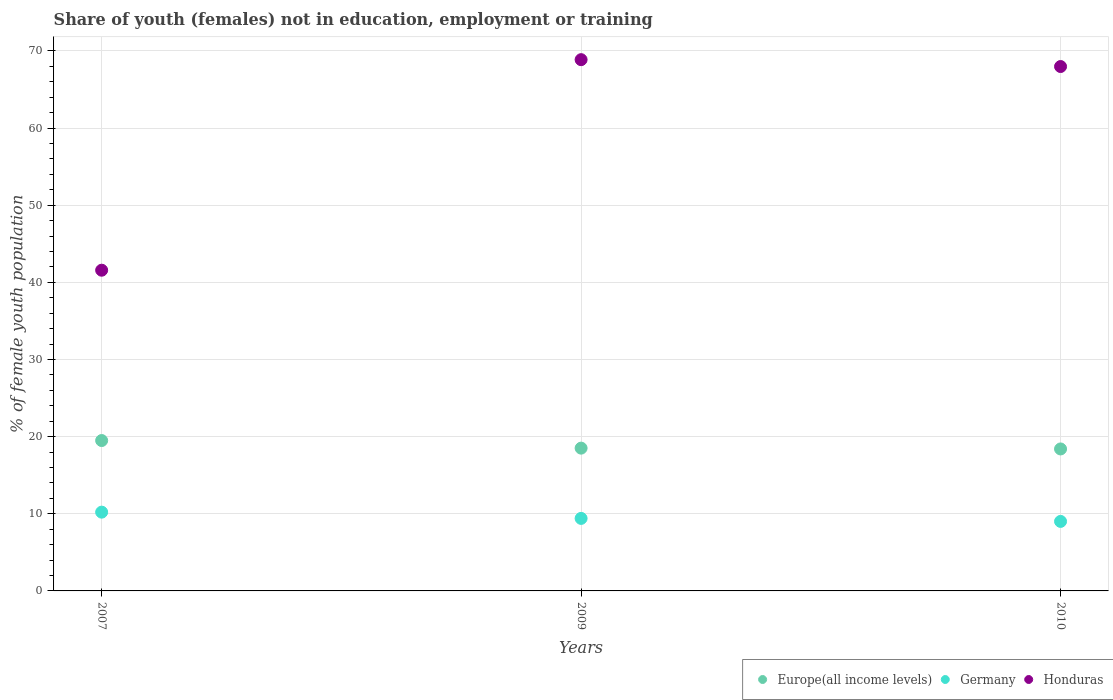What is the percentage of unemployed female population in in Germany in 2010?
Ensure brevity in your answer.  9.01. Across all years, what is the maximum percentage of unemployed female population in in Europe(all income levels)?
Provide a succinct answer. 19.49. Across all years, what is the minimum percentage of unemployed female population in in Germany?
Make the answer very short. 9.01. What is the total percentage of unemployed female population in in Europe(all income levels) in the graph?
Ensure brevity in your answer.  56.4. What is the difference between the percentage of unemployed female population in in Germany in 2007 and that in 2009?
Provide a short and direct response. 0.81. What is the difference between the percentage of unemployed female population in in Europe(all income levels) in 2009 and the percentage of unemployed female population in in Germany in 2010?
Your answer should be very brief. 9.5. What is the average percentage of unemployed female population in in Europe(all income levels) per year?
Offer a terse response. 18.8. In the year 2009, what is the difference between the percentage of unemployed female population in in Germany and percentage of unemployed female population in in Europe(all income levels)?
Your response must be concise. -9.11. What is the ratio of the percentage of unemployed female population in in Germany in 2007 to that in 2010?
Your answer should be very brief. 1.13. Is the percentage of unemployed female population in in Germany in 2007 less than that in 2009?
Give a very brief answer. No. What is the difference between the highest and the second highest percentage of unemployed female population in in Europe(all income levels)?
Make the answer very short. 0.98. What is the difference between the highest and the lowest percentage of unemployed female population in in Germany?
Ensure brevity in your answer.  1.2. In how many years, is the percentage of unemployed female population in in Europe(all income levels) greater than the average percentage of unemployed female population in in Europe(all income levels) taken over all years?
Make the answer very short. 1. Is it the case that in every year, the sum of the percentage of unemployed female population in in Germany and percentage of unemployed female population in in Europe(all income levels)  is greater than the percentage of unemployed female population in in Honduras?
Offer a very short reply. No. Is the percentage of unemployed female population in in Europe(all income levels) strictly greater than the percentage of unemployed female population in in Honduras over the years?
Provide a succinct answer. No. Is the percentage of unemployed female population in in Germany strictly less than the percentage of unemployed female population in in Europe(all income levels) over the years?
Provide a short and direct response. Yes. How many dotlines are there?
Your answer should be very brief. 3. How many years are there in the graph?
Give a very brief answer. 3. What is the difference between two consecutive major ticks on the Y-axis?
Your response must be concise. 10. Are the values on the major ticks of Y-axis written in scientific E-notation?
Make the answer very short. No. Where does the legend appear in the graph?
Ensure brevity in your answer.  Bottom right. What is the title of the graph?
Provide a succinct answer. Share of youth (females) not in education, employment or training. What is the label or title of the Y-axis?
Offer a terse response. % of female youth population. What is the % of female youth population in Europe(all income levels) in 2007?
Offer a terse response. 19.49. What is the % of female youth population in Germany in 2007?
Keep it short and to the point. 10.21. What is the % of female youth population of Honduras in 2007?
Make the answer very short. 41.57. What is the % of female youth population in Europe(all income levels) in 2009?
Keep it short and to the point. 18.51. What is the % of female youth population in Germany in 2009?
Make the answer very short. 9.4. What is the % of female youth population in Honduras in 2009?
Ensure brevity in your answer.  68.86. What is the % of female youth population in Europe(all income levels) in 2010?
Provide a succinct answer. 18.4. What is the % of female youth population of Germany in 2010?
Ensure brevity in your answer.  9.01. What is the % of female youth population in Honduras in 2010?
Your answer should be very brief. 67.97. Across all years, what is the maximum % of female youth population in Europe(all income levels)?
Your answer should be very brief. 19.49. Across all years, what is the maximum % of female youth population of Germany?
Offer a terse response. 10.21. Across all years, what is the maximum % of female youth population of Honduras?
Ensure brevity in your answer.  68.86. Across all years, what is the minimum % of female youth population of Europe(all income levels)?
Your answer should be very brief. 18.4. Across all years, what is the minimum % of female youth population in Germany?
Keep it short and to the point. 9.01. Across all years, what is the minimum % of female youth population of Honduras?
Keep it short and to the point. 41.57. What is the total % of female youth population of Europe(all income levels) in the graph?
Provide a short and direct response. 56.4. What is the total % of female youth population of Germany in the graph?
Your response must be concise. 28.62. What is the total % of female youth population in Honduras in the graph?
Your answer should be very brief. 178.4. What is the difference between the % of female youth population of Europe(all income levels) in 2007 and that in 2009?
Provide a short and direct response. 0.98. What is the difference between the % of female youth population in Germany in 2007 and that in 2009?
Offer a very short reply. 0.81. What is the difference between the % of female youth population in Honduras in 2007 and that in 2009?
Your answer should be compact. -27.29. What is the difference between the % of female youth population in Europe(all income levels) in 2007 and that in 2010?
Your response must be concise. 1.09. What is the difference between the % of female youth population in Germany in 2007 and that in 2010?
Your answer should be very brief. 1.2. What is the difference between the % of female youth population in Honduras in 2007 and that in 2010?
Ensure brevity in your answer.  -26.4. What is the difference between the % of female youth population in Europe(all income levels) in 2009 and that in 2010?
Keep it short and to the point. 0.1. What is the difference between the % of female youth population in Germany in 2009 and that in 2010?
Your response must be concise. 0.39. What is the difference between the % of female youth population in Honduras in 2009 and that in 2010?
Provide a succinct answer. 0.89. What is the difference between the % of female youth population of Europe(all income levels) in 2007 and the % of female youth population of Germany in 2009?
Provide a succinct answer. 10.09. What is the difference between the % of female youth population of Europe(all income levels) in 2007 and the % of female youth population of Honduras in 2009?
Keep it short and to the point. -49.37. What is the difference between the % of female youth population in Germany in 2007 and the % of female youth population in Honduras in 2009?
Provide a succinct answer. -58.65. What is the difference between the % of female youth population in Europe(all income levels) in 2007 and the % of female youth population in Germany in 2010?
Provide a succinct answer. 10.48. What is the difference between the % of female youth population of Europe(all income levels) in 2007 and the % of female youth population of Honduras in 2010?
Offer a terse response. -48.48. What is the difference between the % of female youth population in Germany in 2007 and the % of female youth population in Honduras in 2010?
Offer a terse response. -57.76. What is the difference between the % of female youth population of Europe(all income levels) in 2009 and the % of female youth population of Germany in 2010?
Keep it short and to the point. 9.5. What is the difference between the % of female youth population of Europe(all income levels) in 2009 and the % of female youth population of Honduras in 2010?
Keep it short and to the point. -49.46. What is the difference between the % of female youth population of Germany in 2009 and the % of female youth population of Honduras in 2010?
Make the answer very short. -58.57. What is the average % of female youth population in Europe(all income levels) per year?
Your response must be concise. 18.8. What is the average % of female youth population of Germany per year?
Provide a short and direct response. 9.54. What is the average % of female youth population of Honduras per year?
Provide a succinct answer. 59.47. In the year 2007, what is the difference between the % of female youth population in Europe(all income levels) and % of female youth population in Germany?
Your answer should be compact. 9.28. In the year 2007, what is the difference between the % of female youth population in Europe(all income levels) and % of female youth population in Honduras?
Offer a very short reply. -22.08. In the year 2007, what is the difference between the % of female youth population in Germany and % of female youth population in Honduras?
Give a very brief answer. -31.36. In the year 2009, what is the difference between the % of female youth population of Europe(all income levels) and % of female youth population of Germany?
Offer a terse response. 9.11. In the year 2009, what is the difference between the % of female youth population of Europe(all income levels) and % of female youth population of Honduras?
Offer a very short reply. -50.35. In the year 2009, what is the difference between the % of female youth population in Germany and % of female youth population in Honduras?
Provide a succinct answer. -59.46. In the year 2010, what is the difference between the % of female youth population in Europe(all income levels) and % of female youth population in Germany?
Keep it short and to the point. 9.39. In the year 2010, what is the difference between the % of female youth population in Europe(all income levels) and % of female youth population in Honduras?
Ensure brevity in your answer.  -49.57. In the year 2010, what is the difference between the % of female youth population in Germany and % of female youth population in Honduras?
Your answer should be compact. -58.96. What is the ratio of the % of female youth population of Europe(all income levels) in 2007 to that in 2009?
Provide a succinct answer. 1.05. What is the ratio of the % of female youth population of Germany in 2007 to that in 2009?
Keep it short and to the point. 1.09. What is the ratio of the % of female youth population in Honduras in 2007 to that in 2009?
Make the answer very short. 0.6. What is the ratio of the % of female youth population in Europe(all income levels) in 2007 to that in 2010?
Your answer should be very brief. 1.06. What is the ratio of the % of female youth population in Germany in 2007 to that in 2010?
Your response must be concise. 1.13. What is the ratio of the % of female youth population in Honduras in 2007 to that in 2010?
Provide a short and direct response. 0.61. What is the ratio of the % of female youth population in Europe(all income levels) in 2009 to that in 2010?
Make the answer very short. 1.01. What is the ratio of the % of female youth population of Germany in 2009 to that in 2010?
Keep it short and to the point. 1.04. What is the ratio of the % of female youth population in Honduras in 2009 to that in 2010?
Make the answer very short. 1.01. What is the difference between the highest and the second highest % of female youth population of Europe(all income levels)?
Offer a terse response. 0.98. What is the difference between the highest and the second highest % of female youth population in Germany?
Your response must be concise. 0.81. What is the difference between the highest and the second highest % of female youth population in Honduras?
Offer a terse response. 0.89. What is the difference between the highest and the lowest % of female youth population of Europe(all income levels)?
Offer a very short reply. 1.09. What is the difference between the highest and the lowest % of female youth population in Germany?
Provide a short and direct response. 1.2. What is the difference between the highest and the lowest % of female youth population of Honduras?
Provide a succinct answer. 27.29. 